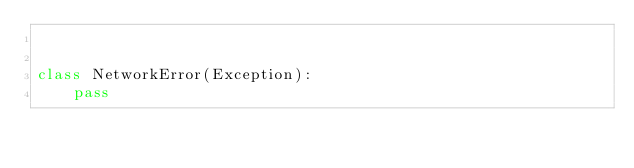Convert code to text. <code><loc_0><loc_0><loc_500><loc_500><_Python_>

class NetworkError(Exception):
    pass
</code> 